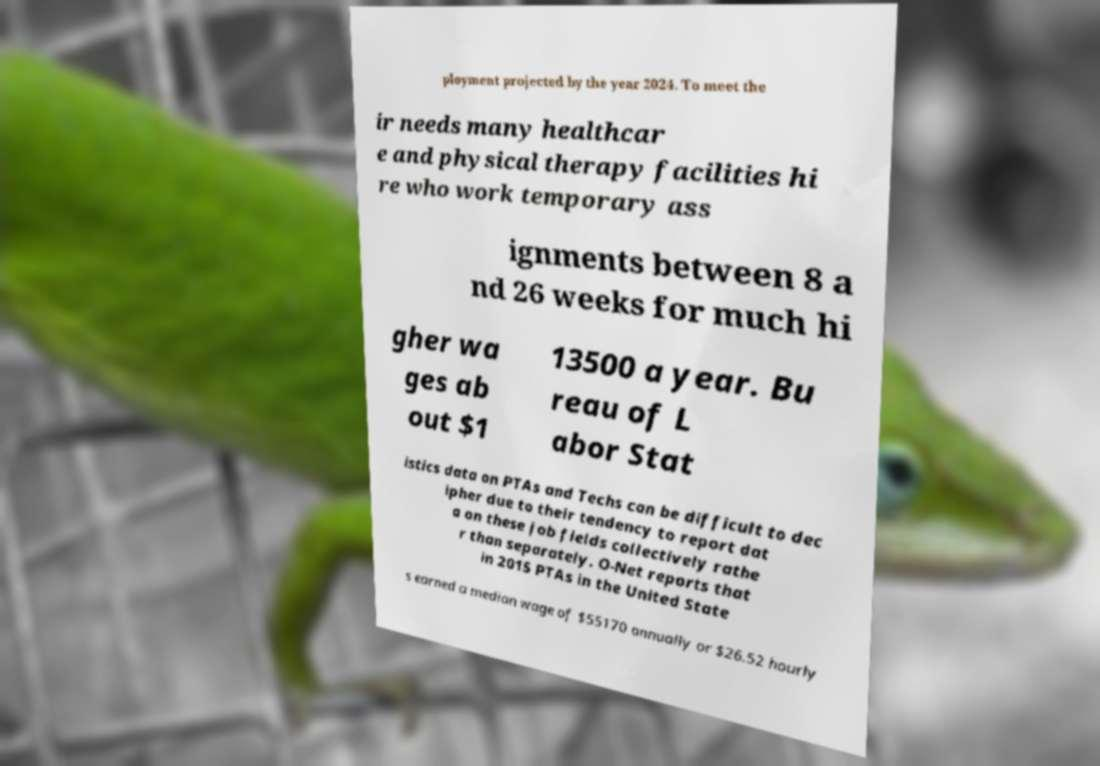Please read and relay the text visible in this image. What does it say? ployment projected by the year 2024. To meet the ir needs many healthcar e and physical therapy facilities hi re who work temporary ass ignments between 8 a nd 26 weeks for much hi gher wa ges ab out $1 13500 a year. Bu reau of L abor Stat istics data on PTAs and Techs can be difficult to dec ipher due to their tendency to report dat a on these job fields collectively rathe r than separately. O-Net reports that in 2015 PTAs in the United State s earned a median wage of $55170 annually or $26.52 hourly 